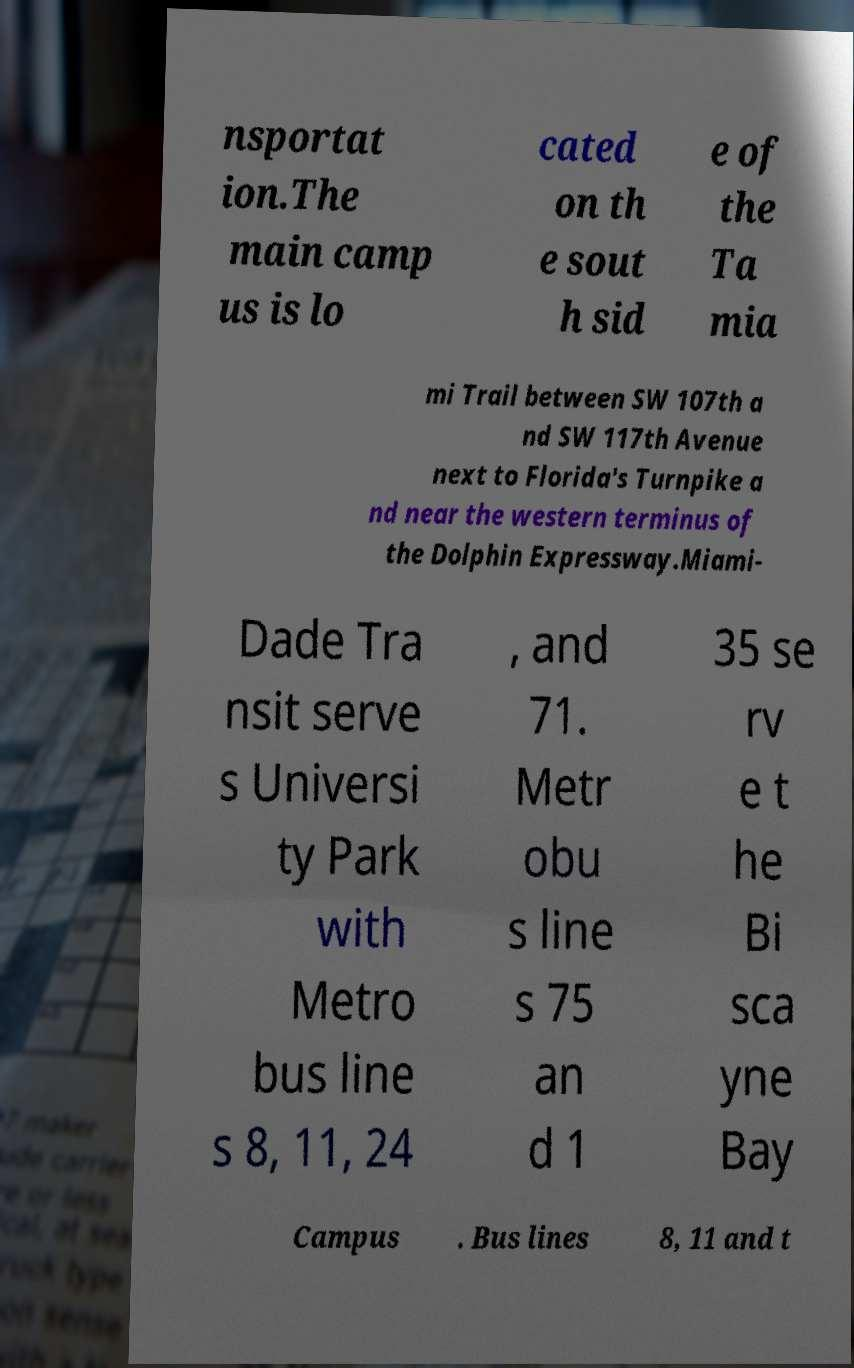What messages or text are displayed in this image? I need them in a readable, typed format. nsportat ion.The main camp us is lo cated on th e sout h sid e of the Ta mia mi Trail between SW 107th a nd SW 117th Avenue next to Florida's Turnpike a nd near the western terminus of the Dolphin Expressway.Miami- Dade Tra nsit serve s Universi ty Park with Metro bus line s 8, 11, 24 , and 71. Metr obu s line s 75 an d 1 35 se rv e t he Bi sca yne Bay Campus . Bus lines 8, 11 and t 